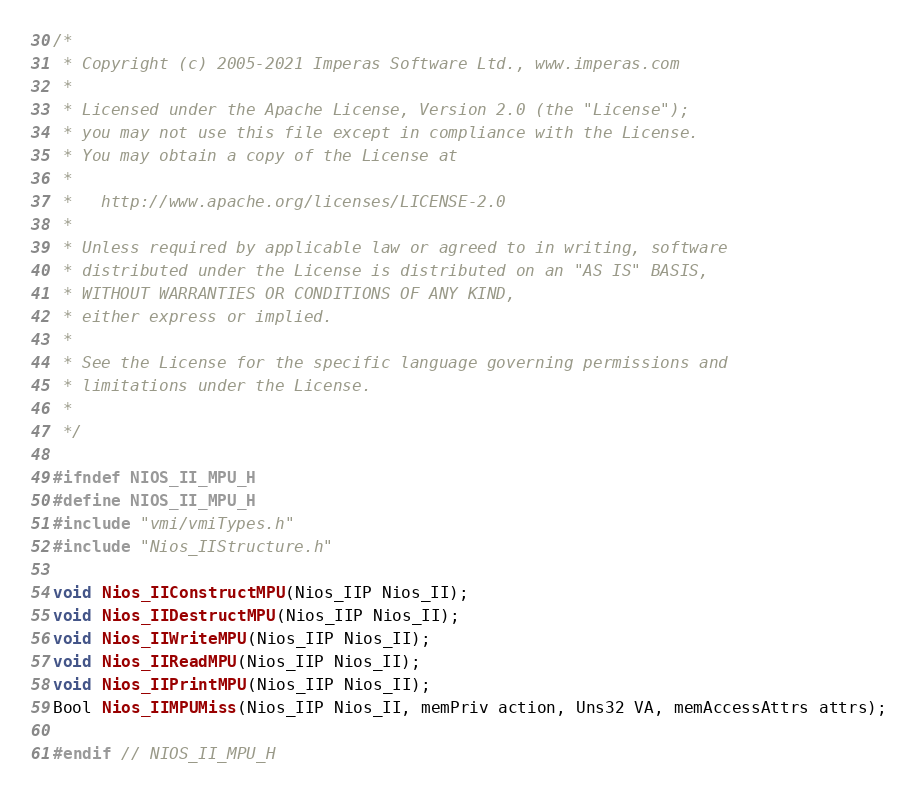Convert code to text. <code><loc_0><loc_0><loc_500><loc_500><_C_>/*
 * Copyright (c) 2005-2021 Imperas Software Ltd., www.imperas.com
 *
 * Licensed under the Apache License, Version 2.0 (the "License");
 * you may not use this file except in compliance with the License.
 * You may obtain a copy of the License at
 *
 *   http://www.apache.org/licenses/LICENSE-2.0
 *
 * Unless required by applicable law or agreed to in writing, software
 * distributed under the License is distributed on an "AS IS" BASIS,
 * WITHOUT WARRANTIES OR CONDITIONS OF ANY KIND,
 * either express or implied.
 *
 * See the License for the specific language governing permissions and
 * limitations under the License.
 *
 */

#ifndef NIOS_II_MPU_H
#define NIOS_II_MPU_H
#include "vmi/vmiTypes.h"
#include "Nios_IIStructure.h"

void Nios_IIConstructMPU(Nios_IIP Nios_II);
void Nios_IIDestructMPU(Nios_IIP Nios_II);
void Nios_IIWriteMPU(Nios_IIP Nios_II);
void Nios_IIReadMPU(Nios_IIP Nios_II);
void Nios_IIPrintMPU(Nios_IIP Nios_II);
Bool Nios_IIMPUMiss(Nios_IIP Nios_II, memPriv action, Uns32 VA, memAccessAttrs attrs);

#endif // NIOS_II_MPU_H
</code> 